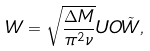<formula> <loc_0><loc_0><loc_500><loc_500>W = \sqrt { \frac { \Delta M } { \pi ^ { 2 } \nu } } U O \tilde { W } ,</formula> 